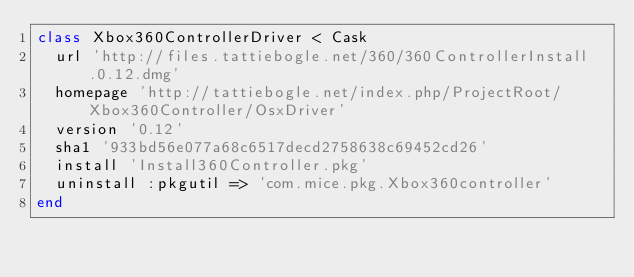Convert code to text. <code><loc_0><loc_0><loc_500><loc_500><_Ruby_>class Xbox360ControllerDriver < Cask
  url 'http://files.tattiebogle.net/360/360ControllerInstall.0.12.dmg'
  homepage 'http://tattiebogle.net/index.php/ProjectRoot/Xbox360Controller/OsxDriver'
  version '0.12'
  sha1 '933bd56e077a68c6517decd2758638c69452cd26'
  install 'Install360Controller.pkg'
  uninstall :pkgutil => 'com.mice.pkg.Xbox360controller'
end
</code> 